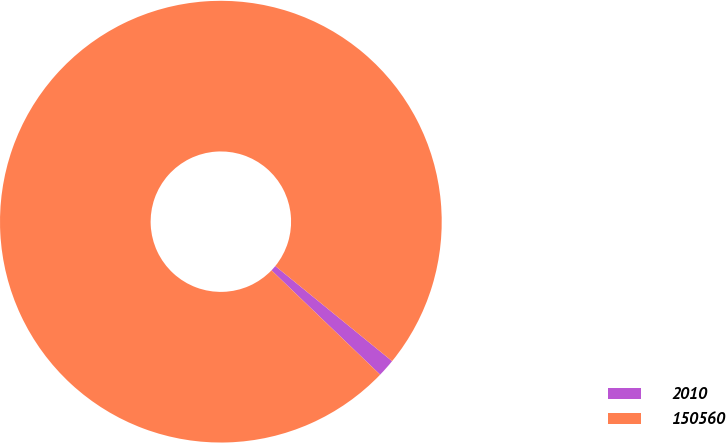Convert chart to OTSL. <chart><loc_0><loc_0><loc_500><loc_500><pie_chart><fcel>2010<fcel>150560<nl><fcel>1.3%<fcel>98.7%<nl></chart> 